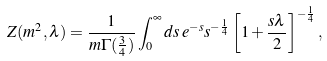<formula> <loc_0><loc_0><loc_500><loc_500>Z ( m ^ { 2 } , \lambda ) = \frac { 1 } { m \Gamma ( \frac { 3 } { 4 } ) } \int _ { 0 } ^ { \infty } d s \, e ^ { - s } s ^ { - \frac { 1 } { 4 } } \left [ 1 + \frac { s \lambda } { 2 } \right ] ^ { - \frac { 1 } { 4 } } ,</formula> 